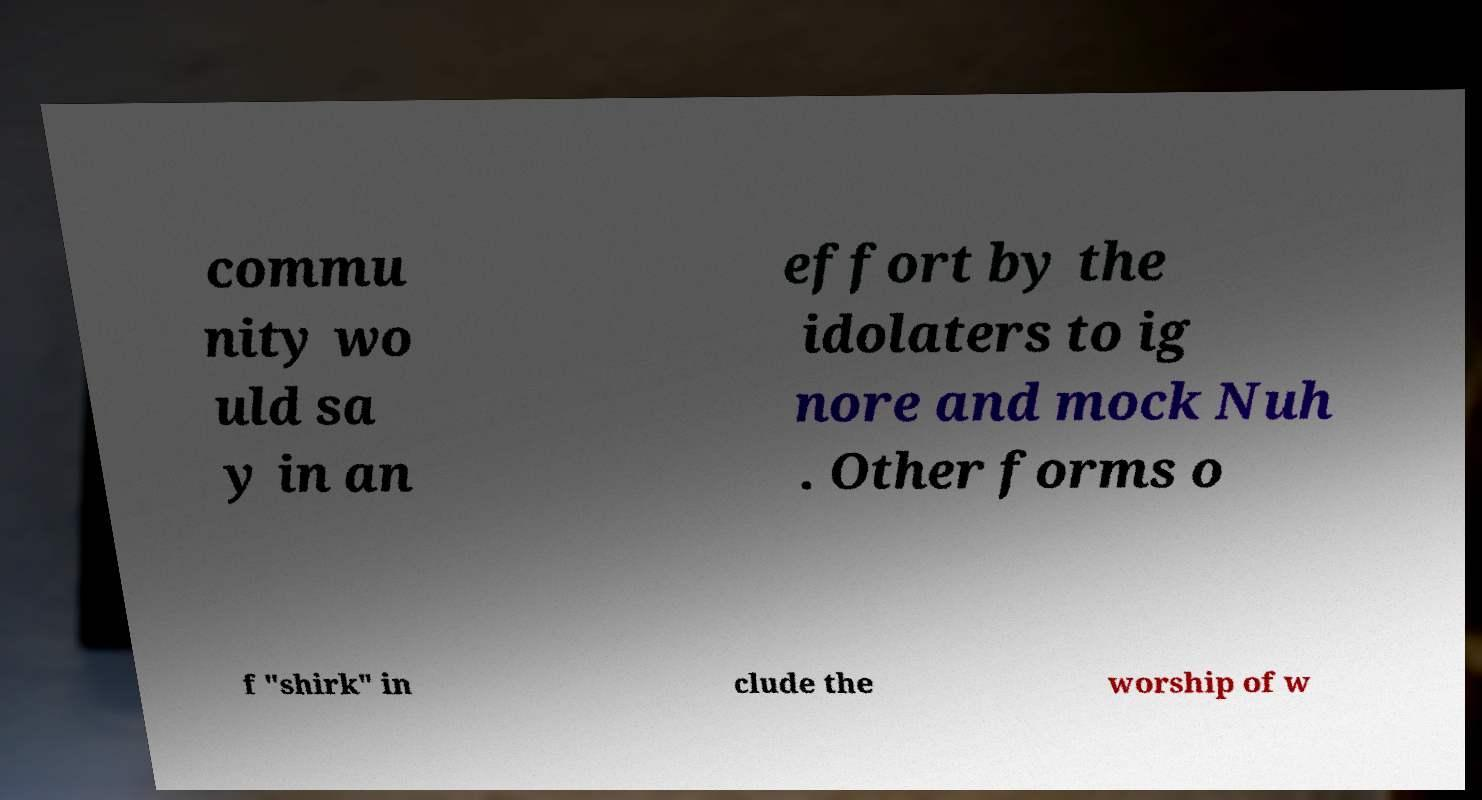Please identify and transcribe the text found in this image. commu nity wo uld sa y in an effort by the idolaters to ig nore and mock Nuh . Other forms o f "shirk" in clude the worship of w 